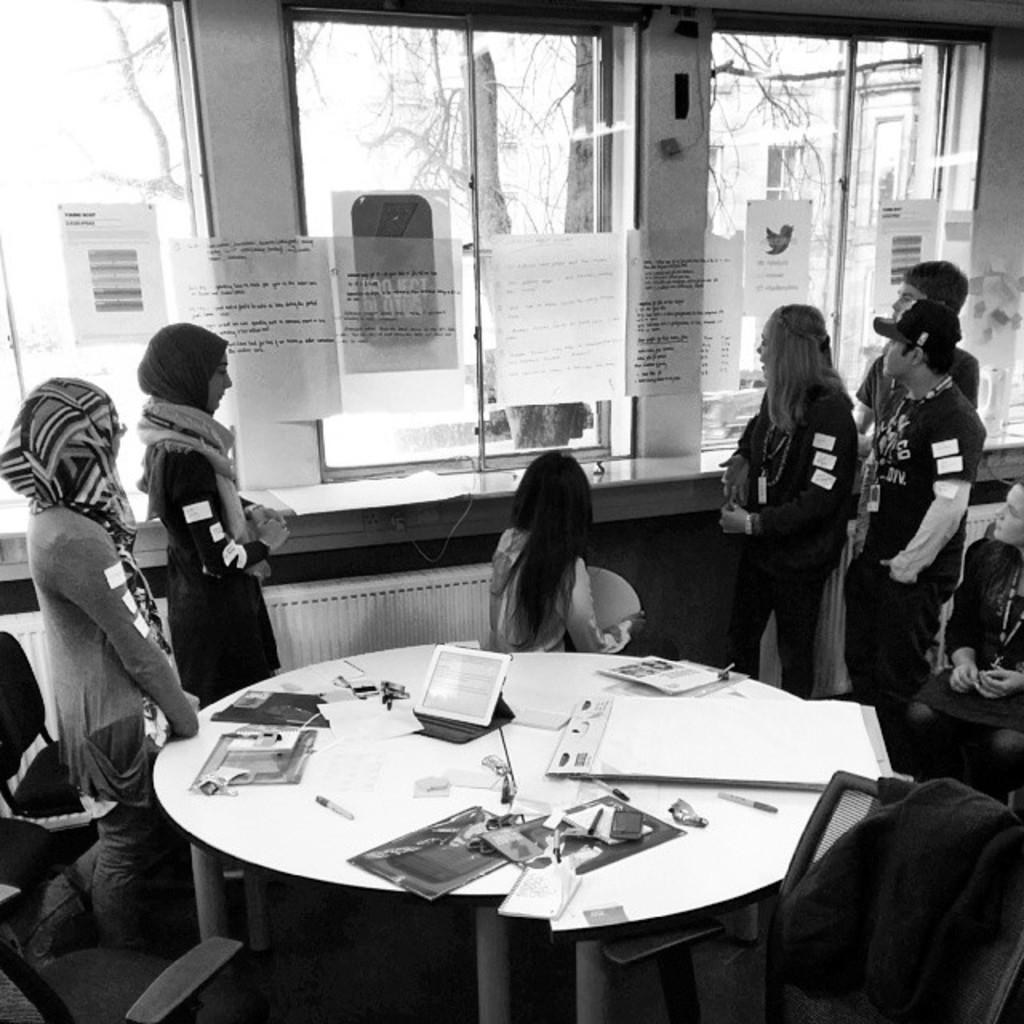What can be seen in the image involving people? There are people standing in the image. What objects are present on the table in the image? There are papers, a pen, and an iPad on the table in the image. Where is the shelf located in the image? There is no shelf present in the image. How much money is on the table in the image? There is no money visible in the image. 